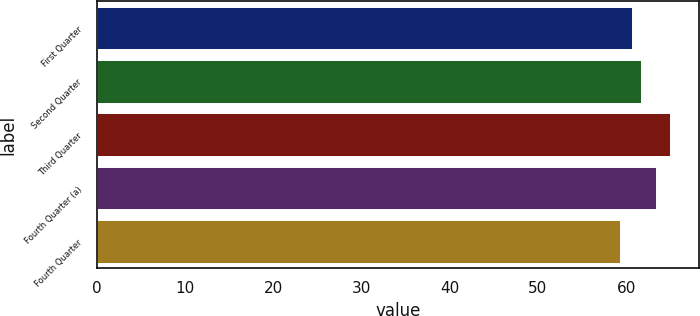<chart> <loc_0><loc_0><loc_500><loc_500><bar_chart><fcel>First Quarter<fcel>Second Quarter<fcel>Third Quarter<fcel>Fourth Quarter (a)<fcel>Fourth Quarter<nl><fcel>60.7<fcel>61.64<fcel>64.99<fcel>63.38<fcel>59.3<nl></chart> 